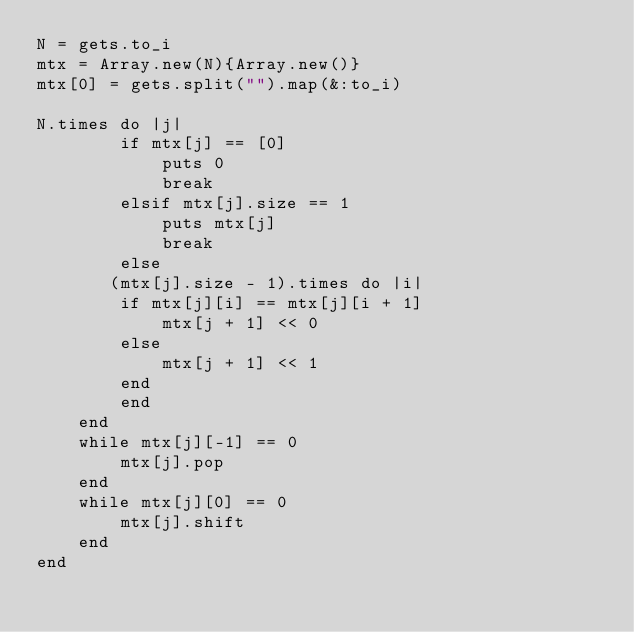Convert code to text. <code><loc_0><loc_0><loc_500><loc_500><_Ruby_>N = gets.to_i
mtx = Array.new(N){Array.new()}
mtx[0] = gets.split("").map(&:to_i)

N.times do |j|
        if mtx[j] == [0]
            puts 0
            break
        elsif mtx[j].size == 1
            puts mtx[j]
            break
        else
       (mtx[j].size - 1).times do |i|
        if mtx[j][i] == mtx[j][i + 1]
            mtx[j + 1] << 0
        else 
            mtx[j + 1] << 1
        end
        end
    end
    while mtx[j][-1] == 0
        mtx[j].pop
    end
    while mtx[j][0] == 0
        mtx[j].shift
    end
end</code> 